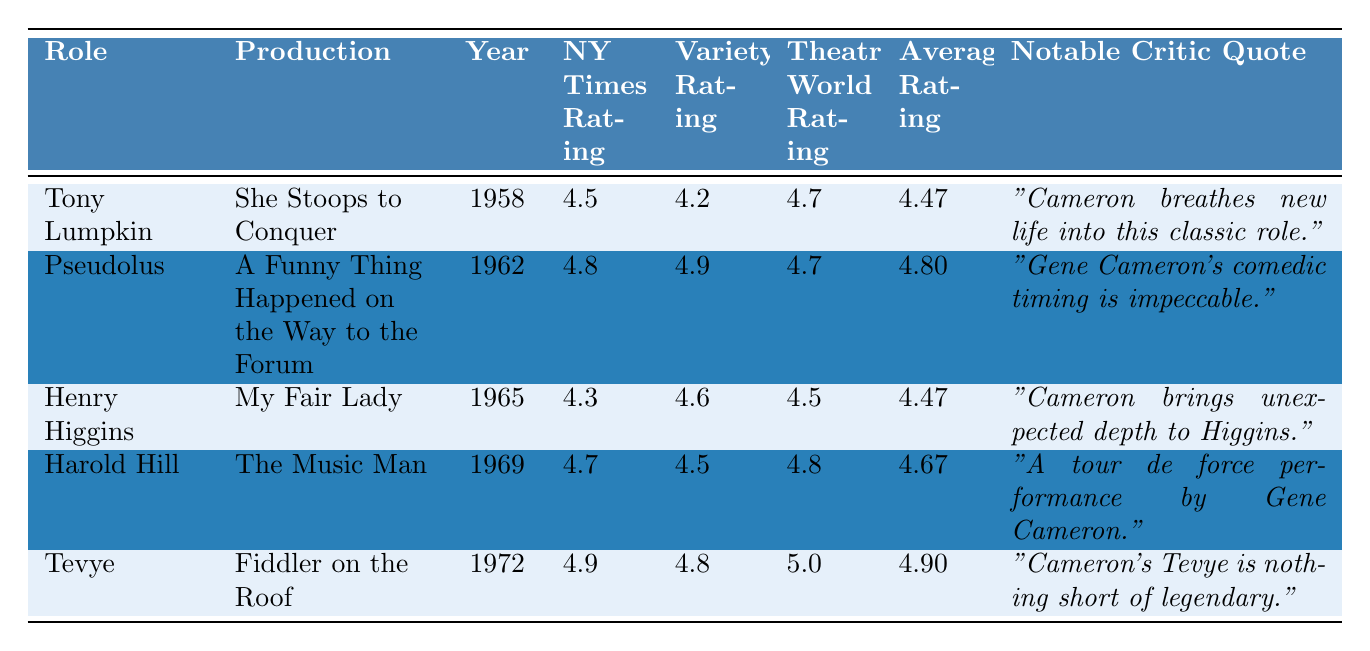What is the highest average rating among Gene Cameron's roles? To find the highest average rating, we look at the "Average Rating" column. The ratings are 4.47, 4.80, 4.47, 4.67, and 4.90. The highest value is 4.90 for the role of Tevye.
Answer: 4.90 Which role received the lowest rating from the NY Times? The "NY Times Rating" for each role is as follows: 4.5, 4.8, 4.3, 4.7, and 4.9. The lowest among these is 4.3 for Henry Higgins.
Answer: Henry Higgins Did any of Gene Cameron's roles receive a perfect 5.0 rating from Theatre World? Looking at the "Theatre World Rating" column, the ratings are 4.7, 4.7, 4.5, 4.8, and 5.0. The role Tevye received a perfect 5.0 rating.
Answer: Yes What is the difference between the highest and lowest Variety ratings? The Variety ratings are 4.2, 4.9, 4.6, 4.5, and 4.8. The highest is 4.9 (Pseudolus) and the lowest is 4.2 (Tony Lumpkin). The difference is 4.9 - 4.2 = 0.7.
Answer: 0.7 Which role had the best review quote? "Cameron's Tevye is nothing short of legendary." for Tevye is considered exceptional compared to others.
Answer: Tevye What was the average rating of all five roles combined? To calculate the average rating, sum the average ratings: 4.47 + 4.80 + 4.47 + 4.67 + 4.90 = 24.31, and then divide by the number of roles (5), which gives 24.31/5 = 4.862.
Answer: 4.862 Which role had both the highest NY Times rating and the highest Theatre World rating? The ratings for NY Times are 4.5, 4.8, 4.3, 4.7, and 4.9, while for Theatre World they are 4.7, 4.7, 4.5, 4.8, and 5.0. Tevye has the highest Theatre World rating of 5.0 but does not have the highest NY Times rating. Pseudolus has the highest NY Times rating of 4.8, but the highest Theatre World rating is for Tevye.
Answer: No Which production features the role with the second-best average rating? The average ratings are 4.47 (Tony Lumpkin), 4.80 (Pseudolus), 4.47 (Henry Higgins), 4.67 (Harold Hill), and 4.90 (Tevye). The second-best is Pseudolus with 4.80 in "A Funny Thing Happened on the Way to the Forum".
Answer: A Funny Thing Happened on the Way to the Forum 